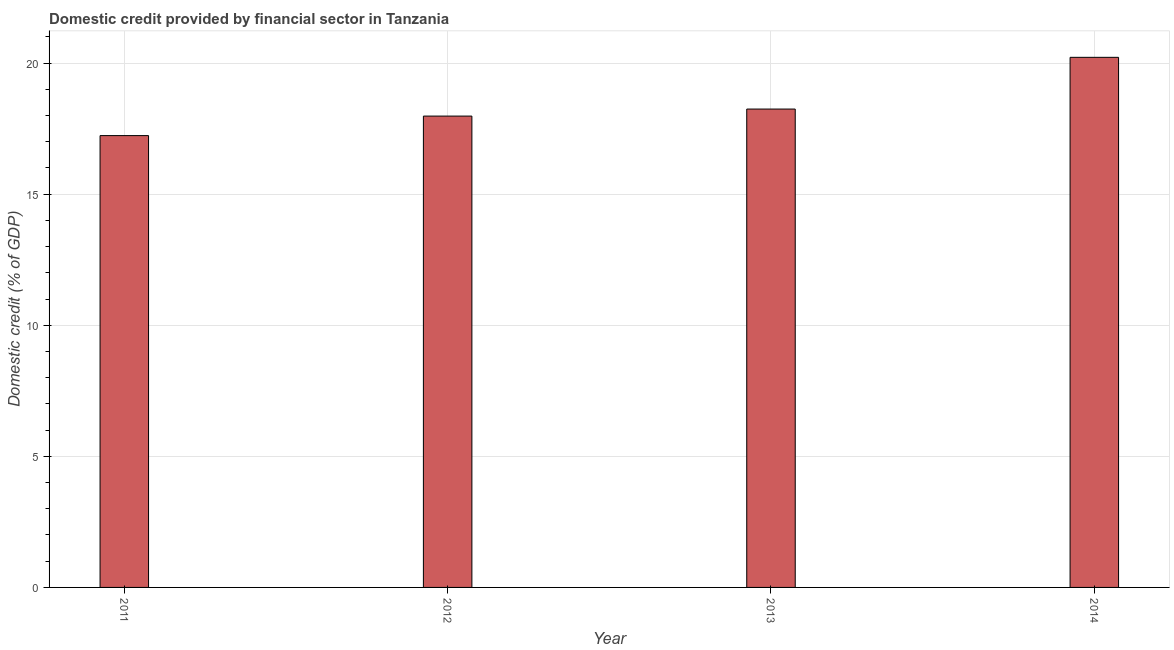What is the title of the graph?
Give a very brief answer. Domestic credit provided by financial sector in Tanzania. What is the label or title of the Y-axis?
Provide a succinct answer. Domestic credit (% of GDP). What is the domestic credit provided by financial sector in 2014?
Provide a short and direct response. 20.22. Across all years, what is the maximum domestic credit provided by financial sector?
Your answer should be very brief. 20.22. Across all years, what is the minimum domestic credit provided by financial sector?
Your answer should be compact. 17.23. What is the sum of the domestic credit provided by financial sector?
Provide a short and direct response. 73.68. What is the difference between the domestic credit provided by financial sector in 2011 and 2012?
Give a very brief answer. -0.74. What is the average domestic credit provided by financial sector per year?
Your answer should be very brief. 18.42. What is the median domestic credit provided by financial sector?
Your answer should be compact. 18.11. In how many years, is the domestic credit provided by financial sector greater than 6 %?
Keep it short and to the point. 4. What is the ratio of the domestic credit provided by financial sector in 2011 to that in 2014?
Offer a very short reply. 0.85. Is the difference between the domestic credit provided by financial sector in 2011 and 2012 greater than the difference between any two years?
Ensure brevity in your answer.  No. What is the difference between the highest and the second highest domestic credit provided by financial sector?
Provide a short and direct response. 1.97. Is the sum of the domestic credit provided by financial sector in 2011 and 2012 greater than the maximum domestic credit provided by financial sector across all years?
Provide a succinct answer. Yes. What is the difference between the highest and the lowest domestic credit provided by financial sector?
Provide a short and direct response. 2.99. In how many years, is the domestic credit provided by financial sector greater than the average domestic credit provided by financial sector taken over all years?
Ensure brevity in your answer.  1. What is the difference between two consecutive major ticks on the Y-axis?
Your answer should be very brief. 5. Are the values on the major ticks of Y-axis written in scientific E-notation?
Offer a terse response. No. What is the Domestic credit (% of GDP) in 2011?
Provide a short and direct response. 17.23. What is the Domestic credit (% of GDP) in 2012?
Keep it short and to the point. 17.98. What is the Domestic credit (% of GDP) of 2013?
Provide a short and direct response. 18.25. What is the Domestic credit (% of GDP) of 2014?
Your response must be concise. 20.22. What is the difference between the Domestic credit (% of GDP) in 2011 and 2012?
Your answer should be very brief. -0.74. What is the difference between the Domestic credit (% of GDP) in 2011 and 2013?
Your answer should be compact. -1.01. What is the difference between the Domestic credit (% of GDP) in 2011 and 2014?
Give a very brief answer. -2.99. What is the difference between the Domestic credit (% of GDP) in 2012 and 2013?
Your answer should be very brief. -0.27. What is the difference between the Domestic credit (% of GDP) in 2012 and 2014?
Ensure brevity in your answer.  -2.24. What is the difference between the Domestic credit (% of GDP) in 2013 and 2014?
Your answer should be compact. -1.97. What is the ratio of the Domestic credit (% of GDP) in 2011 to that in 2013?
Offer a very short reply. 0.94. What is the ratio of the Domestic credit (% of GDP) in 2011 to that in 2014?
Provide a succinct answer. 0.85. What is the ratio of the Domestic credit (% of GDP) in 2012 to that in 2013?
Provide a succinct answer. 0.98. What is the ratio of the Domestic credit (% of GDP) in 2012 to that in 2014?
Your response must be concise. 0.89. What is the ratio of the Domestic credit (% of GDP) in 2013 to that in 2014?
Ensure brevity in your answer.  0.9. 